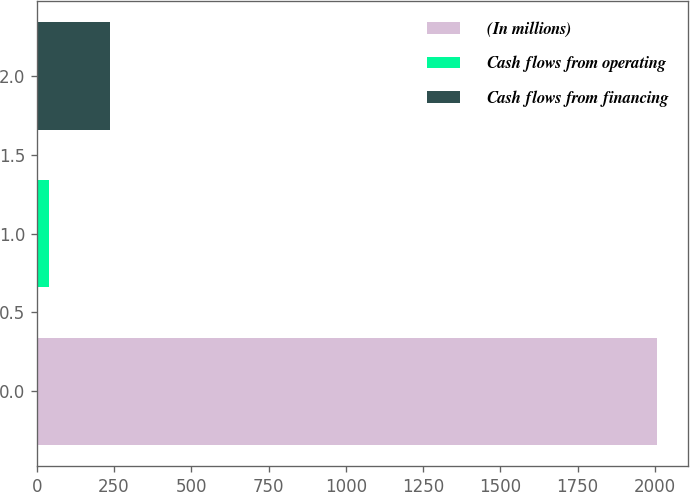Convert chart. <chart><loc_0><loc_0><loc_500><loc_500><bar_chart><fcel>(In millions)<fcel>Cash flows from operating<fcel>Cash flows from financing<nl><fcel>2007<fcel>39<fcel>235.8<nl></chart> 